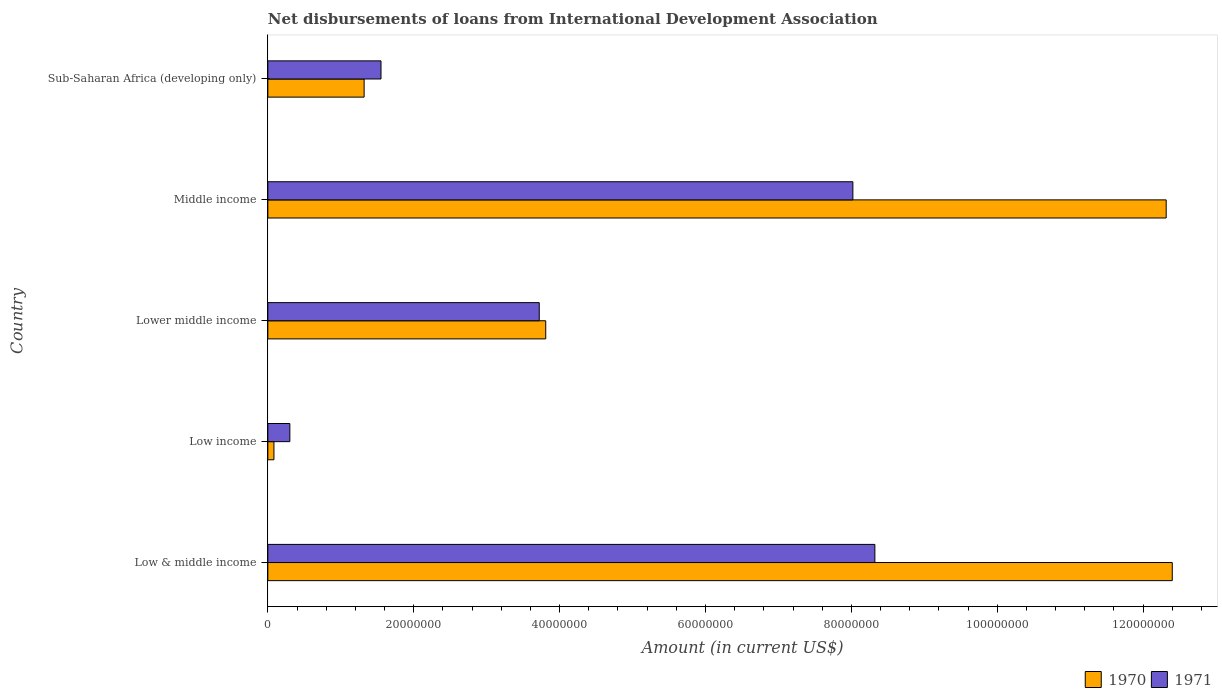How many groups of bars are there?
Provide a short and direct response. 5. How many bars are there on the 2nd tick from the bottom?
Offer a terse response. 2. What is the label of the 3rd group of bars from the top?
Provide a succinct answer. Lower middle income. In how many cases, is the number of bars for a given country not equal to the number of legend labels?
Keep it short and to the point. 0. What is the amount of loans disbursed in 1971 in Middle income?
Your answer should be very brief. 8.02e+07. Across all countries, what is the maximum amount of loans disbursed in 1970?
Provide a short and direct response. 1.24e+08. Across all countries, what is the minimum amount of loans disbursed in 1970?
Ensure brevity in your answer.  8.35e+05. In which country was the amount of loans disbursed in 1971 maximum?
Your response must be concise. Low & middle income. What is the total amount of loans disbursed in 1971 in the graph?
Your response must be concise. 2.19e+08. What is the difference between the amount of loans disbursed in 1971 in Low income and that in Lower middle income?
Your answer should be very brief. -3.42e+07. What is the difference between the amount of loans disbursed in 1971 in Low & middle income and the amount of loans disbursed in 1970 in Sub-Saharan Africa (developing only)?
Provide a short and direct response. 7.00e+07. What is the average amount of loans disbursed in 1971 per country?
Your response must be concise. 4.38e+07. What is the difference between the amount of loans disbursed in 1970 and amount of loans disbursed in 1971 in Lower middle income?
Keep it short and to the point. 8.88e+05. What is the ratio of the amount of loans disbursed in 1970 in Low income to that in Middle income?
Your answer should be compact. 0.01. Is the amount of loans disbursed in 1971 in Low & middle income less than that in Sub-Saharan Africa (developing only)?
Your answer should be very brief. No. Is the difference between the amount of loans disbursed in 1970 in Low & middle income and Low income greater than the difference between the amount of loans disbursed in 1971 in Low & middle income and Low income?
Make the answer very short. Yes. What is the difference between the highest and the second highest amount of loans disbursed in 1970?
Your answer should be very brief. 8.35e+05. What is the difference between the highest and the lowest amount of loans disbursed in 1971?
Your answer should be compact. 8.02e+07. In how many countries, is the amount of loans disbursed in 1970 greater than the average amount of loans disbursed in 1970 taken over all countries?
Your answer should be compact. 2. What does the 2nd bar from the top in Low income represents?
Give a very brief answer. 1970. What does the 1st bar from the bottom in Sub-Saharan Africa (developing only) represents?
Offer a very short reply. 1970. How many bars are there?
Give a very brief answer. 10. Are all the bars in the graph horizontal?
Your answer should be compact. Yes. What is the difference between two consecutive major ticks on the X-axis?
Ensure brevity in your answer.  2.00e+07. Where does the legend appear in the graph?
Make the answer very short. Bottom right. How are the legend labels stacked?
Offer a terse response. Horizontal. What is the title of the graph?
Make the answer very short. Net disbursements of loans from International Development Association. What is the label or title of the X-axis?
Provide a succinct answer. Amount (in current US$). What is the label or title of the Y-axis?
Give a very brief answer. Country. What is the Amount (in current US$) of 1970 in Low & middle income?
Offer a very short reply. 1.24e+08. What is the Amount (in current US$) of 1971 in Low & middle income?
Give a very brief answer. 8.32e+07. What is the Amount (in current US$) in 1970 in Low income?
Keep it short and to the point. 8.35e+05. What is the Amount (in current US$) in 1971 in Low income?
Ensure brevity in your answer.  3.02e+06. What is the Amount (in current US$) of 1970 in Lower middle income?
Provide a short and direct response. 3.81e+07. What is the Amount (in current US$) of 1971 in Lower middle income?
Give a very brief answer. 3.72e+07. What is the Amount (in current US$) in 1970 in Middle income?
Provide a short and direct response. 1.23e+08. What is the Amount (in current US$) of 1971 in Middle income?
Offer a terse response. 8.02e+07. What is the Amount (in current US$) in 1970 in Sub-Saharan Africa (developing only)?
Offer a very short reply. 1.32e+07. What is the Amount (in current US$) in 1971 in Sub-Saharan Africa (developing only)?
Your answer should be compact. 1.55e+07. Across all countries, what is the maximum Amount (in current US$) in 1970?
Give a very brief answer. 1.24e+08. Across all countries, what is the maximum Amount (in current US$) of 1971?
Your answer should be compact. 8.32e+07. Across all countries, what is the minimum Amount (in current US$) in 1970?
Your answer should be very brief. 8.35e+05. Across all countries, what is the minimum Amount (in current US$) in 1971?
Your answer should be very brief. 3.02e+06. What is the total Amount (in current US$) of 1970 in the graph?
Your response must be concise. 2.99e+08. What is the total Amount (in current US$) of 1971 in the graph?
Offer a terse response. 2.19e+08. What is the difference between the Amount (in current US$) of 1970 in Low & middle income and that in Low income?
Offer a terse response. 1.23e+08. What is the difference between the Amount (in current US$) of 1971 in Low & middle income and that in Low income?
Offer a very short reply. 8.02e+07. What is the difference between the Amount (in current US$) of 1970 in Low & middle income and that in Lower middle income?
Make the answer very short. 8.59e+07. What is the difference between the Amount (in current US$) of 1971 in Low & middle income and that in Lower middle income?
Your answer should be compact. 4.60e+07. What is the difference between the Amount (in current US$) in 1970 in Low & middle income and that in Middle income?
Provide a succinct answer. 8.35e+05. What is the difference between the Amount (in current US$) of 1971 in Low & middle income and that in Middle income?
Offer a terse response. 3.02e+06. What is the difference between the Amount (in current US$) of 1970 in Low & middle income and that in Sub-Saharan Africa (developing only)?
Give a very brief answer. 1.11e+08. What is the difference between the Amount (in current US$) of 1971 in Low & middle income and that in Sub-Saharan Africa (developing only)?
Offer a very short reply. 6.77e+07. What is the difference between the Amount (in current US$) in 1970 in Low income and that in Lower middle income?
Give a very brief answer. -3.73e+07. What is the difference between the Amount (in current US$) in 1971 in Low income and that in Lower middle income?
Your response must be concise. -3.42e+07. What is the difference between the Amount (in current US$) of 1970 in Low income and that in Middle income?
Your response must be concise. -1.22e+08. What is the difference between the Amount (in current US$) in 1971 in Low income and that in Middle income?
Provide a short and direct response. -7.72e+07. What is the difference between the Amount (in current US$) of 1970 in Low income and that in Sub-Saharan Africa (developing only)?
Provide a short and direct response. -1.24e+07. What is the difference between the Amount (in current US$) of 1971 in Low income and that in Sub-Saharan Africa (developing only)?
Make the answer very short. -1.25e+07. What is the difference between the Amount (in current US$) of 1970 in Lower middle income and that in Middle income?
Your response must be concise. -8.51e+07. What is the difference between the Amount (in current US$) in 1971 in Lower middle income and that in Middle income?
Your response must be concise. -4.30e+07. What is the difference between the Amount (in current US$) in 1970 in Lower middle income and that in Sub-Saharan Africa (developing only)?
Provide a short and direct response. 2.49e+07. What is the difference between the Amount (in current US$) in 1971 in Lower middle income and that in Sub-Saharan Africa (developing only)?
Keep it short and to the point. 2.17e+07. What is the difference between the Amount (in current US$) in 1970 in Middle income and that in Sub-Saharan Africa (developing only)?
Your answer should be compact. 1.10e+08. What is the difference between the Amount (in current US$) in 1971 in Middle income and that in Sub-Saharan Africa (developing only)?
Keep it short and to the point. 6.47e+07. What is the difference between the Amount (in current US$) in 1970 in Low & middle income and the Amount (in current US$) in 1971 in Low income?
Provide a succinct answer. 1.21e+08. What is the difference between the Amount (in current US$) of 1970 in Low & middle income and the Amount (in current US$) of 1971 in Lower middle income?
Provide a short and direct response. 8.68e+07. What is the difference between the Amount (in current US$) in 1970 in Low & middle income and the Amount (in current US$) in 1971 in Middle income?
Make the answer very short. 4.38e+07. What is the difference between the Amount (in current US$) in 1970 in Low & middle income and the Amount (in current US$) in 1971 in Sub-Saharan Africa (developing only)?
Keep it short and to the point. 1.08e+08. What is the difference between the Amount (in current US$) of 1970 in Low income and the Amount (in current US$) of 1971 in Lower middle income?
Your response must be concise. -3.64e+07. What is the difference between the Amount (in current US$) in 1970 in Low income and the Amount (in current US$) in 1971 in Middle income?
Offer a very short reply. -7.94e+07. What is the difference between the Amount (in current US$) in 1970 in Low income and the Amount (in current US$) in 1971 in Sub-Saharan Africa (developing only)?
Offer a terse response. -1.47e+07. What is the difference between the Amount (in current US$) of 1970 in Lower middle income and the Amount (in current US$) of 1971 in Middle income?
Your response must be concise. -4.21e+07. What is the difference between the Amount (in current US$) in 1970 in Lower middle income and the Amount (in current US$) in 1971 in Sub-Saharan Africa (developing only)?
Your answer should be very brief. 2.26e+07. What is the difference between the Amount (in current US$) in 1970 in Middle income and the Amount (in current US$) in 1971 in Sub-Saharan Africa (developing only)?
Offer a terse response. 1.08e+08. What is the average Amount (in current US$) of 1970 per country?
Ensure brevity in your answer.  5.99e+07. What is the average Amount (in current US$) of 1971 per country?
Make the answer very short. 4.38e+07. What is the difference between the Amount (in current US$) in 1970 and Amount (in current US$) in 1971 in Low & middle income?
Ensure brevity in your answer.  4.08e+07. What is the difference between the Amount (in current US$) of 1970 and Amount (in current US$) of 1971 in Low income?
Your answer should be very brief. -2.18e+06. What is the difference between the Amount (in current US$) of 1970 and Amount (in current US$) of 1971 in Lower middle income?
Keep it short and to the point. 8.88e+05. What is the difference between the Amount (in current US$) in 1970 and Amount (in current US$) in 1971 in Middle income?
Your answer should be very brief. 4.30e+07. What is the difference between the Amount (in current US$) of 1970 and Amount (in current US$) of 1971 in Sub-Saharan Africa (developing only)?
Offer a very short reply. -2.31e+06. What is the ratio of the Amount (in current US$) in 1970 in Low & middle income to that in Low income?
Your answer should be very brief. 148.5. What is the ratio of the Amount (in current US$) in 1971 in Low & middle income to that in Low income?
Keep it short and to the point. 27.59. What is the ratio of the Amount (in current US$) in 1970 in Low & middle income to that in Lower middle income?
Make the answer very short. 3.25. What is the ratio of the Amount (in current US$) in 1971 in Low & middle income to that in Lower middle income?
Ensure brevity in your answer.  2.24. What is the ratio of the Amount (in current US$) in 1970 in Low & middle income to that in Middle income?
Make the answer very short. 1.01. What is the ratio of the Amount (in current US$) of 1971 in Low & middle income to that in Middle income?
Offer a very short reply. 1.04. What is the ratio of the Amount (in current US$) of 1970 in Low & middle income to that in Sub-Saharan Africa (developing only)?
Your response must be concise. 9.39. What is the ratio of the Amount (in current US$) in 1971 in Low & middle income to that in Sub-Saharan Africa (developing only)?
Provide a short and direct response. 5.36. What is the ratio of the Amount (in current US$) of 1970 in Low income to that in Lower middle income?
Keep it short and to the point. 0.02. What is the ratio of the Amount (in current US$) of 1971 in Low income to that in Lower middle income?
Your answer should be compact. 0.08. What is the ratio of the Amount (in current US$) in 1970 in Low income to that in Middle income?
Make the answer very short. 0.01. What is the ratio of the Amount (in current US$) of 1971 in Low income to that in Middle income?
Provide a short and direct response. 0.04. What is the ratio of the Amount (in current US$) of 1970 in Low income to that in Sub-Saharan Africa (developing only)?
Provide a succinct answer. 0.06. What is the ratio of the Amount (in current US$) in 1971 in Low income to that in Sub-Saharan Africa (developing only)?
Provide a succinct answer. 0.19. What is the ratio of the Amount (in current US$) of 1970 in Lower middle income to that in Middle income?
Provide a short and direct response. 0.31. What is the ratio of the Amount (in current US$) of 1971 in Lower middle income to that in Middle income?
Provide a short and direct response. 0.46. What is the ratio of the Amount (in current US$) of 1970 in Lower middle income to that in Sub-Saharan Africa (developing only)?
Your response must be concise. 2.89. What is the ratio of the Amount (in current US$) in 1971 in Lower middle income to that in Sub-Saharan Africa (developing only)?
Provide a succinct answer. 2.4. What is the ratio of the Amount (in current US$) of 1970 in Middle income to that in Sub-Saharan Africa (developing only)?
Ensure brevity in your answer.  9.33. What is the ratio of the Amount (in current US$) in 1971 in Middle income to that in Sub-Saharan Africa (developing only)?
Ensure brevity in your answer.  5.17. What is the difference between the highest and the second highest Amount (in current US$) of 1970?
Offer a very short reply. 8.35e+05. What is the difference between the highest and the second highest Amount (in current US$) in 1971?
Offer a terse response. 3.02e+06. What is the difference between the highest and the lowest Amount (in current US$) in 1970?
Keep it short and to the point. 1.23e+08. What is the difference between the highest and the lowest Amount (in current US$) of 1971?
Offer a terse response. 8.02e+07. 